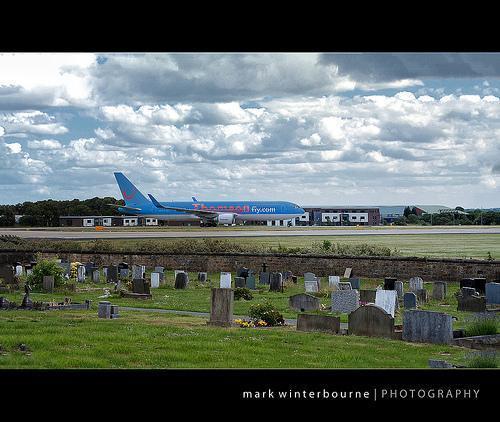How many plane wings are visible?
Give a very brief answer. 1. 